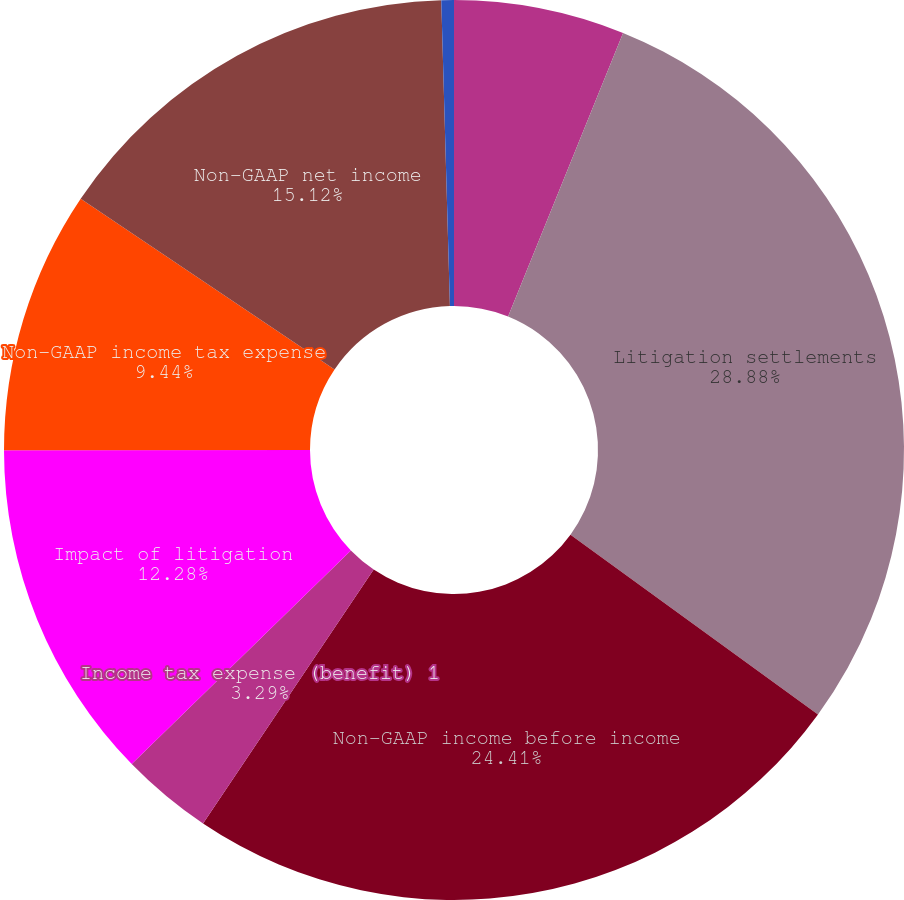<chart> <loc_0><loc_0><loc_500><loc_500><pie_chart><fcel>GAAP income (loss) before<fcel>Litigation settlements<fcel>Non-GAAP income before income<fcel>Income tax expense (benefit) 1<fcel>Impact of litigation<fcel>Non-GAAP income tax expense<fcel>Non-GAAP net income<fcel>Non-GAAP effective tax rate<nl><fcel>6.13%<fcel>28.87%<fcel>24.41%<fcel>3.29%<fcel>12.28%<fcel>9.44%<fcel>15.12%<fcel>0.45%<nl></chart> 